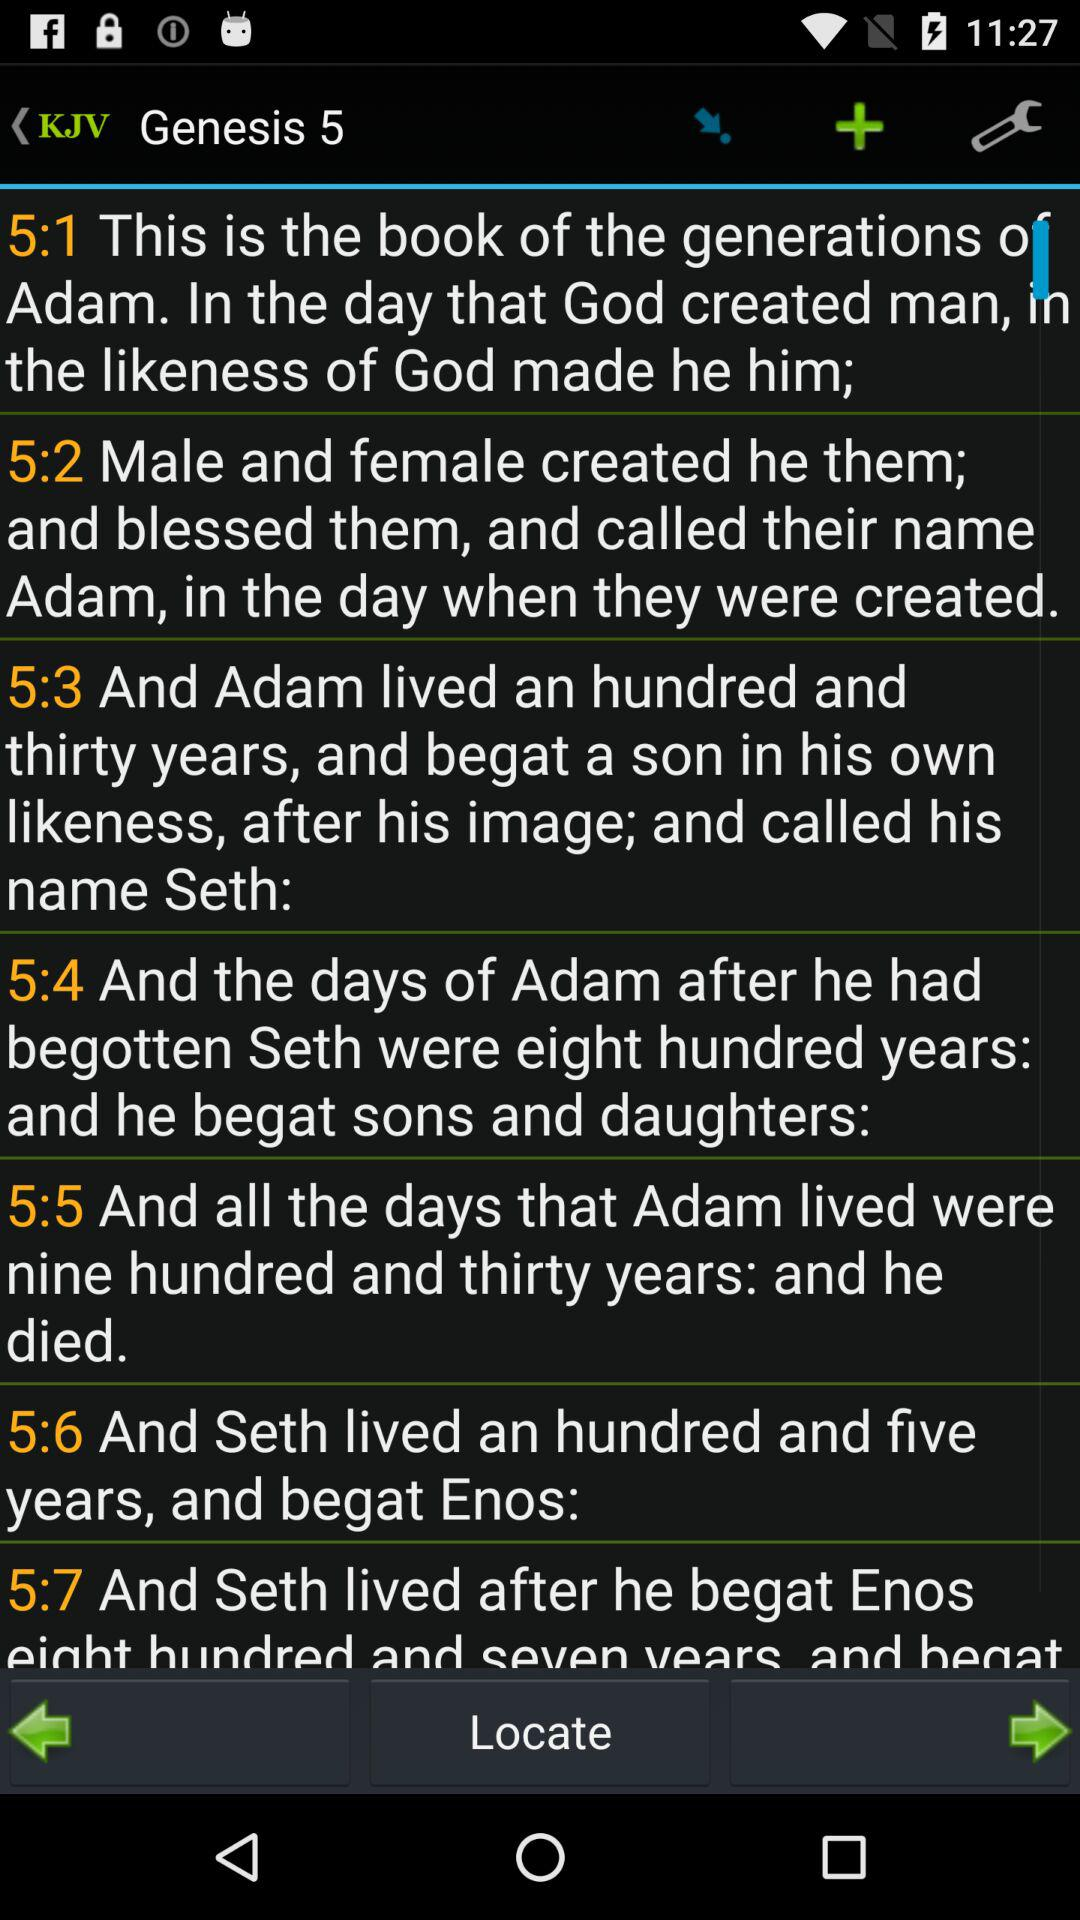At what Genesis are we right now? You are on Genesis 5. 